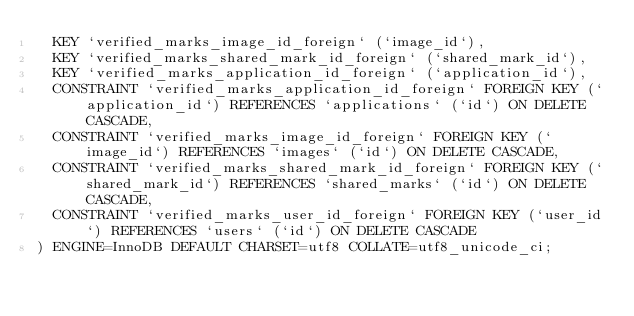<code> <loc_0><loc_0><loc_500><loc_500><_SQL_>  KEY `verified_marks_image_id_foreign` (`image_id`),
  KEY `verified_marks_shared_mark_id_foreign` (`shared_mark_id`),
  KEY `verified_marks_application_id_foreign` (`application_id`),
  CONSTRAINT `verified_marks_application_id_foreign` FOREIGN KEY (`application_id`) REFERENCES `applications` (`id`) ON DELETE CASCADE,
  CONSTRAINT `verified_marks_image_id_foreign` FOREIGN KEY (`image_id`) REFERENCES `images` (`id`) ON DELETE CASCADE,
  CONSTRAINT `verified_marks_shared_mark_id_foreign` FOREIGN KEY (`shared_mark_id`) REFERENCES `shared_marks` (`id`) ON DELETE CASCADE,
  CONSTRAINT `verified_marks_user_id_foreign` FOREIGN KEY (`user_id`) REFERENCES `users` (`id`) ON DELETE CASCADE
) ENGINE=InnoDB DEFAULT CHARSET=utf8 COLLATE=utf8_unicode_ci;</code> 